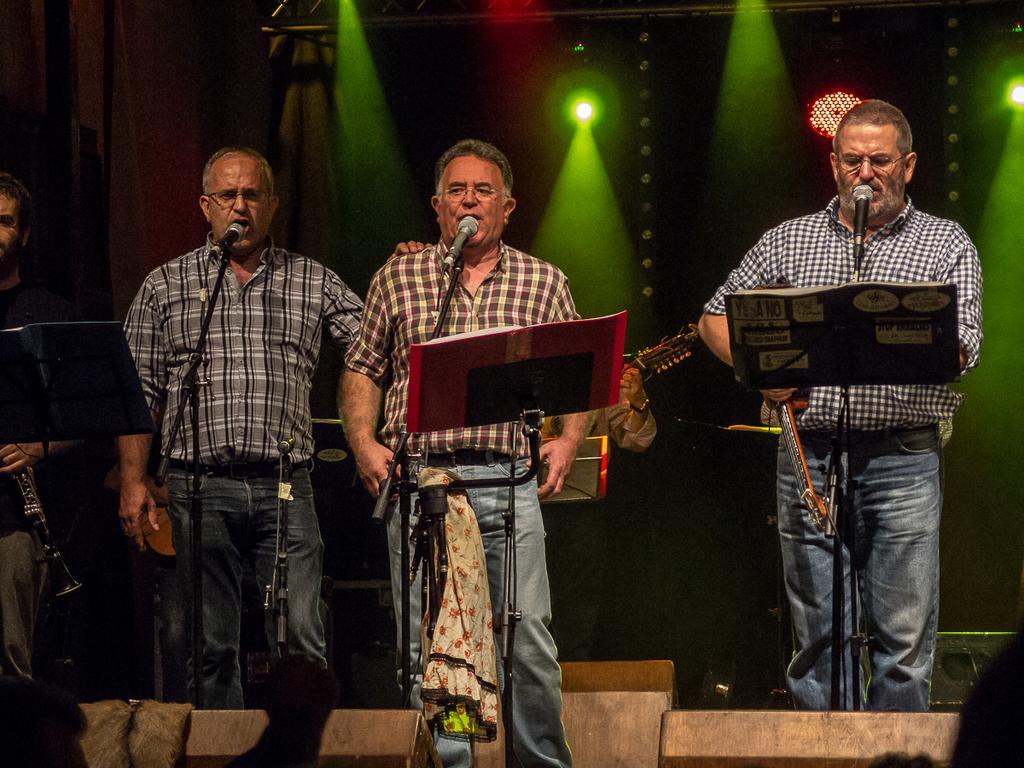In one or two sentences, can you explain what this image depicts? There are three persons standing and singing a song. this is a mike with a mike stand. This is a book holder. At background I can see a man playing a musical instrument. At background I can see a green color show light. At the very left corner of the image I can see a man Standing and holding some musical instrument. 